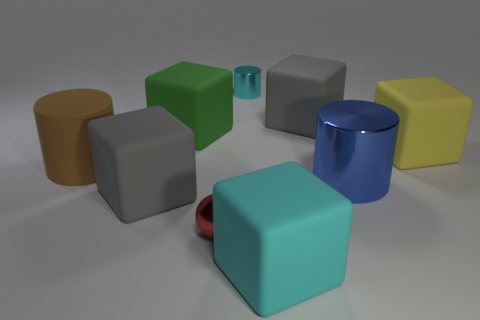Are there more cyan shiny cylinders than metal cylinders? There is an equal number of cyan shiny cylinders and metal cylinders in the image, with one of each visibly presented. 